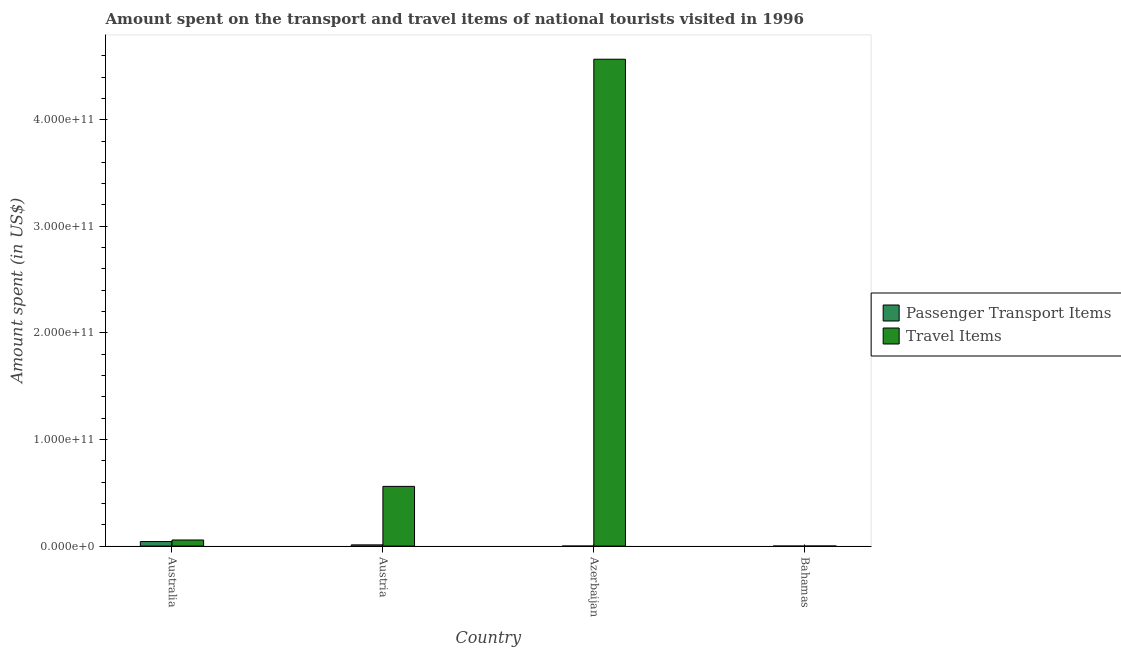How many different coloured bars are there?
Your answer should be compact. 2. How many groups of bars are there?
Offer a very short reply. 4. How many bars are there on the 2nd tick from the left?
Ensure brevity in your answer.  2. What is the label of the 3rd group of bars from the left?
Make the answer very short. Azerbaijan. In how many cases, is the number of bars for a given country not equal to the number of legend labels?
Give a very brief answer. 0. What is the amount spent on passenger transport items in Australia?
Ensure brevity in your answer.  4.26e+09. Across all countries, what is the maximum amount spent on passenger transport items?
Your answer should be very brief. 4.26e+09. Across all countries, what is the minimum amount spent in travel items?
Keep it short and to the point. 7.70e+07. In which country was the amount spent in travel items maximum?
Provide a short and direct response. Azerbaijan. In which country was the amount spent on passenger transport items minimum?
Offer a very short reply. Azerbaijan. What is the total amount spent in travel items in the graph?
Offer a terse response. 5.19e+11. What is the difference between the amount spent on passenger transport items in Australia and that in Austria?
Ensure brevity in your answer.  3.11e+09. What is the difference between the amount spent on passenger transport items in Azerbaijan and the amount spent in travel items in Austria?
Provide a short and direct response. -5.60e+1. What is the average amount spent on passenger transport items per country?
Offer a very short reply. 1.36e+09. What is the difference between the amount spent on passenger transport items and amount spent in travel items in Bahamas?
Keep it short and to the point. -6.60e+07. In how many countries, is the amount spent in travel items greater than 340000000000 US$?
Provide a succinct answer. 1. What is the ratio of the amount spent in travel items in Australia to that in Azerbaijan?
Your answer should be compact. 0.01. What is the difference between the highest and the second highest amount spent on passenger transport items?
Keep it short and to the point. 3.11e+09. What is the difference between the highest and the lowest amount spent in travel items?
Keep it short and to the point. 4.57e+11. Is the sum of the amount spent on passenger transport items in Australia and Bahamas greater than the maximum amount spent in travel items across all countries?
Your response must be concise. No. What does the 2nd bar from the left in Austria represents?
Offer a terse response. Travel Items. What does the 2nd bar from the right in Australia represents?
Make the answer very short. Passenger Transport Items. How many bars are there?
Offer a terse response. 8. Are all the bars in the graph horizontal?
Give a very brief answer. No. What is the difference between two consecutive major ticks on the Y-axis?
Keep it short and to the point. 1.00e+11. Does the graph contain any zero values?
Provide a succinct answer. No. Does the graph contain grids?
Your answer should be compact. No. Where does the legend appear in the graph?
Keep it short and to the point. Center right. How many legend labels are there?
Offer a very short reply. 2. What is the title of the graph?
Give a very brief answer. Amount spent on the transport and travel items of national tourists visited in 1996. What is the label or title of the Y-axis?
Your answer should be very brief. Amount spent (in US$). What is the Amount spent (in US$) in Passenger Transport Items in Australia?
Ensure brevity in your answer.  4.26e+09. What is the Amount spent (in US$) in Travel Items in Australia?
Offer a terse response. 5.73e+09. What is the Amount spent (in US$) of Passenger Transport Items in Austria?
Offer a very short reply. 1.15e+09. What is the Amount spent (in US$) in Travel Items in Austria?
Your response must be concise. 5.60e+1. What is the Amount spent (in US$) of Passenger Transport Items in Azerbaijan?
Make the answer very short. 1.10e+07. What is the Amount spent (in US$) in Travel Items in Azerbaijan?
Your answer should be compact. 4.57e+11. What is the Amount spent (in US$) of Passenger Transport Items in Bahamas?
Make the answer very short. 1.10e+07. What is the Amount spent (in US$) of Travel Items in Bahamas?
Provide a short and direct response. 7.70e+07. Across all countries, what is the maximum Amount spent (in US$) in Passenger Transport Items?
Offer a terse response. 4.26e+09. Across all countries, what is the maximum Amount spent (in US$) in Travel Items?
Provide a short and direct response. 4.57e+11. Across all countries, what is the minimum Amount spent (in US$) in Passenger Transport Items?
Provide a succinct answer. 1.10e+07. Across all countries, what is the minimum Amount spent (in US$) of Travel Items?
Your response must be concise. 7.70e+07. What is the total Amount spent (in US$) of Passenger Transport Items in the graph?
Give a very brief answer. 5.43e+09. What is the total Amount spent (in US$) in Travel Items in the graph?
Your response must be concise. 5.19e+11. What is the difference between the Amount spent (in US$) in Passenger Transport Items in Australia and that in Austria?
Give a very brief answer. 3.11e+09. What is the difference between the Amount spent (in US$) in Travel Items in Australia and that in Austria?
Your response must be concise. -5.03e+1. What is the difference between the Amount spent (in US$) of Passenger Transport Items in Australia and that in Azerbaijan?
Keep it short and to the point. 4.25e+09. What is the difference between the Amount spent (in US$) in Travel Items in Australia and that in Azerbaijan?
Ensure brevity in your answer.  -4.51e+11. What is the difference between the Amount spent (in US$) of Passenger Transport Items in Australia and that in Bahamas?
Your answer should be compact. 4.25e+09. What is the difference between the Amount spent (in US$) of Travel Items in Australia and that in Bahamas?
Your answer should be very brief. 5.65e+09. What is the difference between the Amount spent (in US$) of Passenger Transport Items in Austria and that in Azerbaijan?
Your answer should be compact. 1.14e+09. What is the difference between the Amount spent (in US$) of Travel Items in Austria and that in Azerbaijan?
Provide a short and direct response. -4.01e+11. What is the difference between the Amount spent (in US$) in Passenger Transport Items in Austria and that in Bahamas?
Make the answer very short. 1.14e+09. What is the difference between the Amount spent (in US$) in Travel Items in Austria and that in Bahamas?
Ensure brevity in your answer.  5.59e+1. What is the difference between the Amount spent (in US$) in Passenger Transport Items in Azerbaijan and that in Bahamas?
Ensure brevity in your answer.  0. What is the difference between the Amount spent (in US$) of Travel Items in Azerbaijan and that in Bahamas?
Offer a terse response. 4.57e+11. What is the difference between the Amount spent (in US$) in Passenger Transport Items in Australia and the Amount spent (in US$) in Travel Items in Austria?
Provide a short and direct response. -5.18e+1. What is the difference between the Amount spent (in US$) of Passenger Transport Items in Australia and the Amount spent (in US$) of Travel Items in Azerbaijan?
Provide a short and direct response. -4.52e+11. What is the difference between the Amount spent (in US$) of Passenger Transport Items in Australia and the Amount spent (in US$) of Travel Items in Bahamas?
Provide a succinct answer. 4.18e+09. What is the difference between the Amount spent (in US$) in Passenger Transport Items in Austria and the Amount spent (in US$) in Travel Items in Azerbaijan?
Your response must be concise. -4.56e+11. What is the difference between the Amount spent (in US$) in Passenger Transport Items in Austria and the Amount spent (in US$) in Travel Items in Bahamas?
Your response must be concise. 1.07e+09. What is the difference between the Amount spent (in US$) of Passenger Transport Items in Azerbaijan and the Amount spent (in US$) of Travel Items in Bahamas?
Ensure brevity in your answer.  -6.60e+07. What is the average Amount spent (in US$) in Passenger Transport Items per country?
Make the answer very short. 1.36e+09. What is the average Amount spent (in US$) of Travel Items per country?
Provide a succinct answer. 1.30e+11. What is the difference between the Amount spent (in US$) of Passenger Transport Items and Amount spent (in US$) of Travel Items in Australia?
Provide a succinct answer. -1.47e+09. What is the difference between the Amount spent (in US$) in Passenger Transport Items and Amount spent (in US$) in Travel Items in Austria?
Provide a succinct answer. -5.49e+1. What is the difference between the Amount spent (in US$) in Passenger Transport Items and Amount spent (in US$) in Travel Items in Azerbaijan?
Your answer should be compact. -4.57e+11. What is the difference between the Amount spent (in US$) of Passenger Transport Items and Amount spent (in US$) of Travel Items in Bahamas?
Provide a short and direct response. -6.60e+07. What is the ratio of the Amount spent (in US$) in Passenger Transport Items in Australia to that in Austria?
Keep it short and to the point. 3.7. What is the ratio of the Amount spent (in US$) in Travel Items in Australia to that in Austria?
Provide a succinct answer. 0.1. What is the ratio of the Amount spent (in US$) of Passenger Transport Items in Australia to that in Azerbaijan?
Keep it short and to the point. 387.27. What is the ratio of the Amount spent (in US$) in Travel Items in Australia to that in Azerbaijan?
Your answer should be very brief. 0.01. What is the ratio of the Amount spent (in US$) in Passenger Transport Items in Australia to that in Bahamas?
Ensure brevity in your answer.  387.27. What is the ratio of the Amount spent (in US$) in Travel Items in Australia to that in Bahamas?
Your answer should be compact. 74.43. What is the ratio of the Amount spent (in US$) in Passenger Transport Items in Austria to that in Azerbaijan?
Keep it short and to the point. 104.55. What is the ratio of the Amount spent (in US$) of Travel Items in Austria to that in Azerbaijan?
Ensure brevity in your answer.  0.12. What is the ratio of the Amount spent (in US$) of Passenger Transport Items in Austria to that in Bahamas?
Ensure brevity in your answer.  104.55. What is the ratio of the Amount spent (in US$) of Travel Items in Austria to that in Bahamas?
Your answer should be very brief. 727.52. What is the ratio of the Amount spent (in US$) in Travel Items in Azerbaijan to that in Bahamas?
Give a very brief answer. 5931.82. What is the difference between the highest and the second highest Amount spent (in US$) in Passenger Transport Items?
Give a very brief answer. 3.11e+09. What is the difference between the highest and the second highest Amount spent (in US$) in Travel Items?
Provide a short and direct response. 4.01e+11. What is the difference between the highest and the lowest Amount spent (in US$) in Passenger Transport Items?
Your answer should be very brief. 4.25e+09. What is the difference between the highest and the lowest Amount spent (in US$) of Travel Items?
Keep it short and to the point. 4.57e+11. 